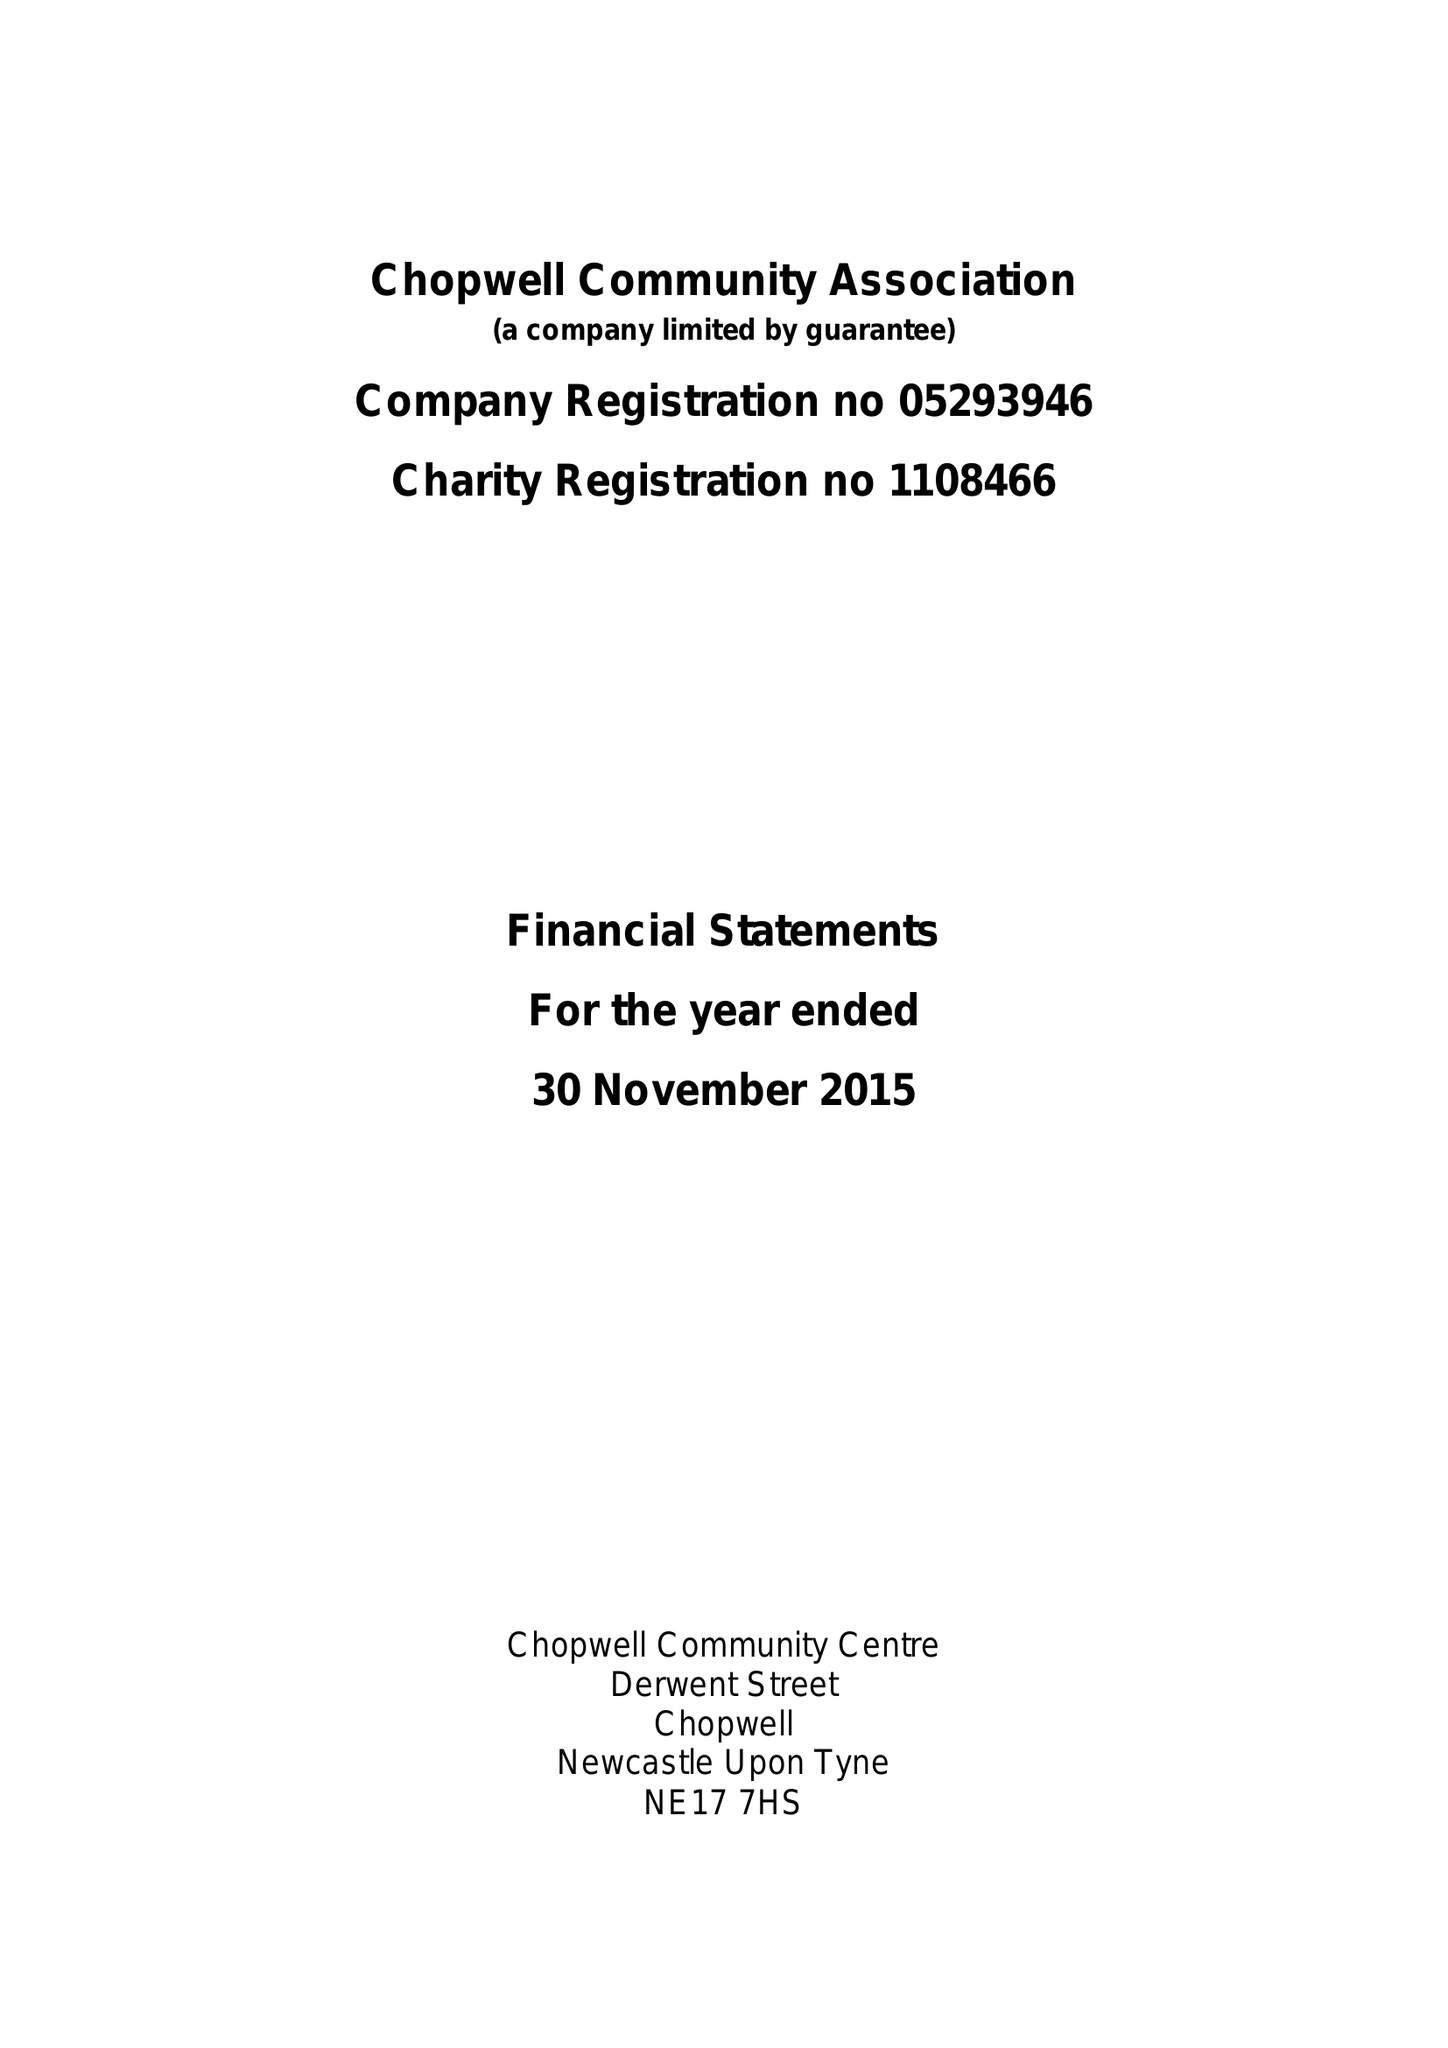What is the value for the address__postcode?
Answer the question using a single word or phrase. NE17 7HA 